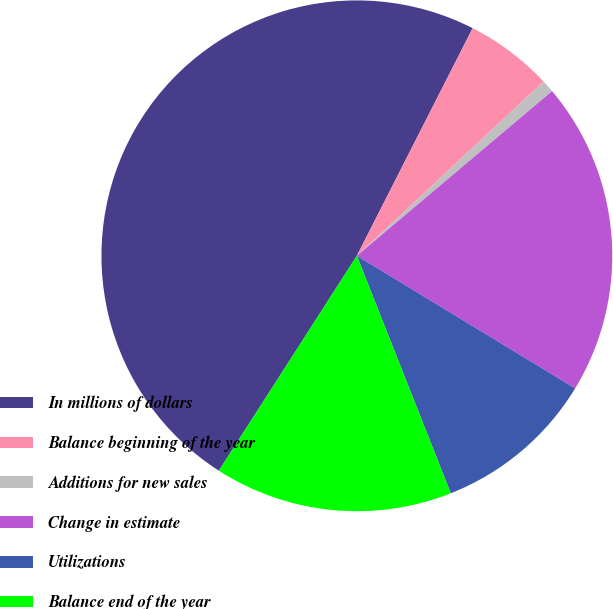Convert chart. <chart><loc_0><loc_0><loc_500><loc_500><pie_chart><fcel>In millions of dollars<fcel>Balance beginning of the year<fcel>Additions for new sales<fcel>Change in estimate<fcel>Utilizations<fcel>Balance end of the year<nl><fcel>48.41%<fcel>5.56%<fcel>0.8%<fcel>19.84%<fcel>10.32%<fcel>15.08%<nl></chart> 